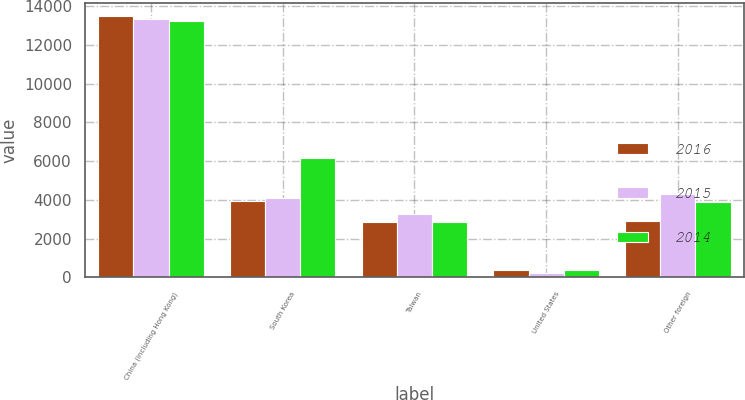Convert chart to OTSL. <chart><loc_0><loc_0><loc_500><loc_500><stacked_bar_chart><ecel><fcel>China (including Hong Kong)<fcel>South Korea<fcel>Taiwan<fcel>United States<fcel>Other foreign<nl><fcel>2016<fcel>13503<fcel>3918<fcel>2846<fcel>386<fcel>2901<nl><fcel>2015<fcel>13337<fcel>4107<fcel>3294<fcel>246<fcel>4297<nl><fcel>2014<fcel>13200<fcel>6172<fcel>2876<fcel>372<fcel>3867<nl></chart> 